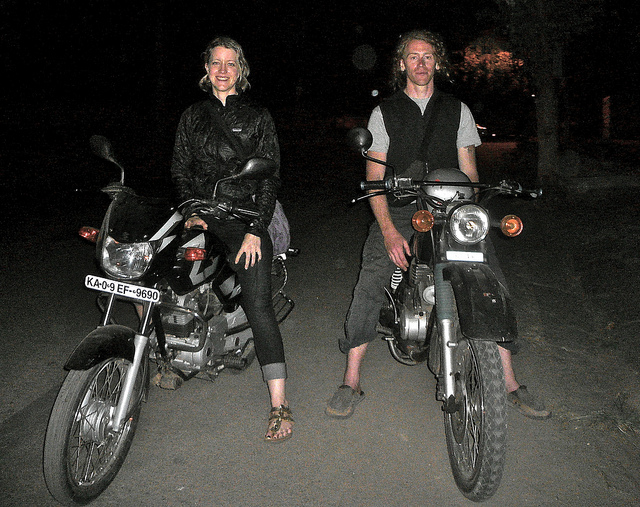Please transcribe the text in this image. KA-0-9 EF--9690 